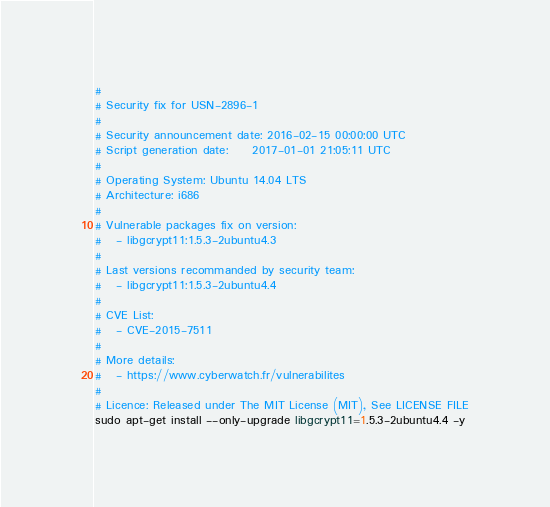<code> <loc_0><loc_0><loc_500><loc_500><_Bash_>#
# Security fix for USN-2896-1
#
# Security announcement date: 2016-02-15 00:00:00 UTC
# Script generation date:     2017-01-01 21:05:11 UTC
#
# Operating System: Ubuntu 14.04 LTS
# Architecture: i686
#
# Vulnerable packages fix on version:
#   - libgcrypt11:1.5.3-2ubuntu4.3
#
# Last versions recommanded by security team:
#   - libgcrypt11:1.5.3-2ubuntu4.4
#
# CVE List:
#   - CVE-2015-7511
#
# More details:
#   - https://www.cyberwatch.fr/vulnerabilites
#
# Licence: Released under The MIT License (MIT), See LICENSE FILE
sudo apt-get install --only-upgrade libgcrypt11=1.5.3-2ubuntu4.4 -y
</code> 